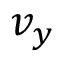<formula> <loc_0><loc_0><loc_500><loc_500>v _ { y }</formula> 